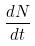<formula> <loc_0><loc_0><loc_500><loc_500>\frac { d N } { d t }</formula> 